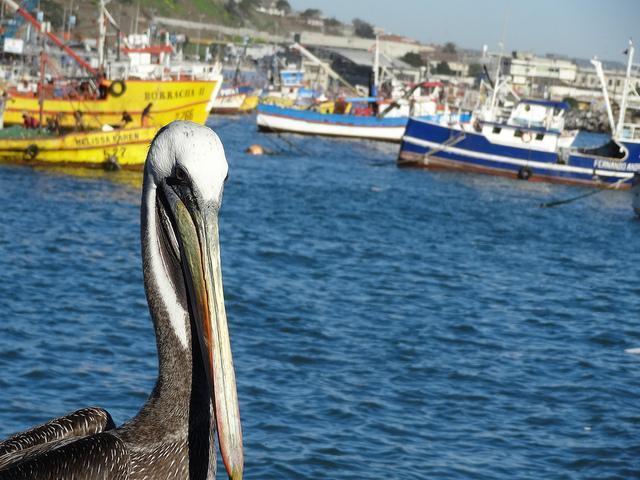On what continent was this photo most likely taken?
Indicate the correct response and explain using: 'Answer: answer
Rationale: rationale.'
Options: North america, south america, europe, africa. Answer: south america.
Rationale: The pelican is from south america. 